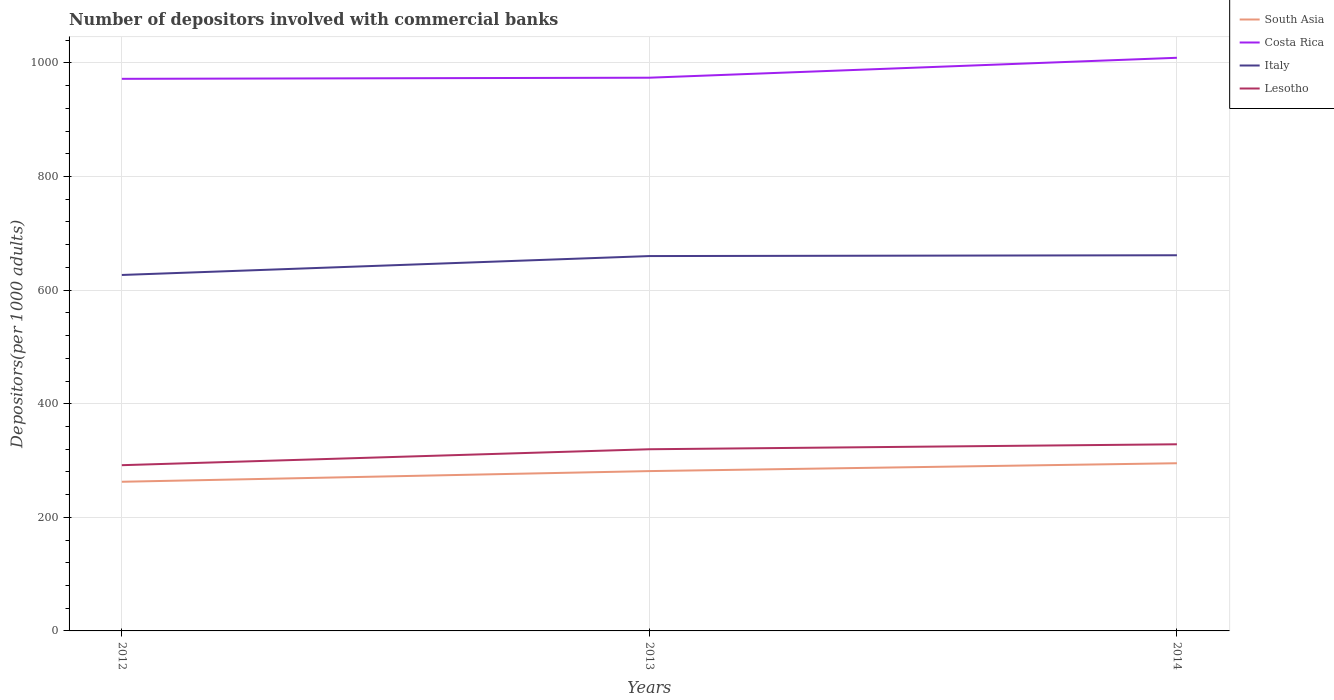Does the line corresponding to Italy intersect with the line corresponding to Costa Rica?
Offer a very short reply. No. Across all years, what is the maximum number of depositors involved with commercial banks in South Asia?
Your answer should be compact. 262.6. In which year was the number of depositors involved with commercial banks in Lesotho maximum?
Your answer should be compact. 2012. What is the total number of depositors involved with commercial banks in Costa Rica in the graph?
Your answer should be compact. -37.08. What is the difference between the highest and the second highest number of depositors involved with commercial banks in South Asia?
Offer a terse response. 32.63. What is the difference between the highest and the lowest number of depositors involved with commercial banks in South Asia?
Offer a very short reply. 2. What is the difference between two consecutive major ticks on the Y-axis?
Make the answer very short. 200. Does the graph contain grids?
Ensure brevity in your answer.  Yes. Where does the legend appear in the graph?
Your answer should be compact. Top right. How many legend labels are there?
Your answer should be compact. 4. How are the legend labels stacked?
Your answer should be compact. Vertical. What is the title of the graph?
Your response must be concise. Number of depositors involved with commercial banks. Does "Turks and Caicos Islands" appear as one of the legend labels in the graph?
Your response must be concise. No. What is the label or title of the Y-axis?
Offer a terse response. Depositors(per 1000 adults). What is the Depositors(per 1000 adults) of South Asia in 2012?
Make the answer very short. 262.6. What is the Depositors(per 1000 adults) of Costa Rica in 2012?
Keep it short and to the point. 972. What is the Depositors(per 1000 adults) of Italy in 2012?
Offer a terse response. 626.68. What is the Depositors(per 1000 adults) of Lesotho in 2012?
Provide a short and direct response. 291.78. What is the Depositors(per 1000 adults) in South Asia in 2013?
Make the answer very short. 281.38. What is the Depositors(per 1000 adults) of Costa Rica in 2013?
Provide a succinct answer. 974. What is the Depositors(per 1000 adults) in Italy in 2013?
Your response must be concise. 659.98. What is the Depositors(per 1000 adults) in Lesotho in 2013?
Your response must be concise. 319.84. What is the Depositors(per 1000 adults) of South Asia in 2014?
Provide a succinct answer. 295.23. What is the Depositors(per 1000 adults) of Costa Rica in 2014?
Offer a terse response. 1009.08. What is the Depositors(per 1000 adults) in Italy in 2014?
Offer a terse response. 661.41. What is the Depositors(per 1000 adults) in Lesotho in 2014?
Your answer should be very brief. 328.59. Across all years, what is the maximum Depositors(per 1000 adults) of South Asia?
Give a very brief answer. 295.23. Across all years, what is the maximum Depositors(per 1000 adults) of Costa Rica?
Offer a terse response. 1009.08. Across all years, what is the maximum Depositors(per 1000 adults) of Italy?
Keep it short and to the point. 661.41. Across all years, what is the maximum Depositors(per 1000 adults) of Lesotho?
Offer a terse response. 328.59. Across all years, what is the minimum Depositors(per 1000 adults) of South Asia?
Your response must be concise. 262.6. Across all years, what is the minimum Depositors(per 1000 adults) of Costa Rica?
Your answer should be compact. 972. Across all years, what is the minimum Depositors(per 1000 adults) of Italy?
Keep it short and to the point. 626.68. Across all years, what is the minimum Depositors(per 1000 adults) of Lesotho?
Provide a succinct answer. 291.78. What is the total Depositors(per 1000 adults) of South Asia in the graph?
Offer a terse response. 839.21. What is the total Depositors(per 1000 adults) of Costa Rica in the graph?
Give a very brief answer. 2955.08. What is the total Depositors(per 1000 adults) of Italy in the graph?
Your answer should be very brief. 1948.07. What is the total Depositors(per 1000 adults) in Lesotho in the graph?
Your response must be concise. 940.21. What is the difference between the Depositors(per 1000 adults) of South Asia in 2012 and that in 2013?
Your answer should be very brief. -18.78. What is the difference between the Depositors(per 1000 adults) in Costa Rica in 2012 and that in 2013?
Give a very brief answer. -2. What is the difference between the Depositors(per 1000 adults) of Italy in 2012 and that in 2013?
Your response must be concise. -33.3. What is the difference between the Depositors(per 1000 adults) of Lesotho in 2012 and that in 2013?
Offer a terse response. -28.06. What is the difference between the Depositors(per 1000 adults) of South Asia in 2012 and that in 2014?
Provide a succinct answer. -32.63. What is the difference between the Depositors(per 1000 adults) in Costa Rica in 2012 and that in 2014?
Offer a terse response. -37.08. What is the difference between the Depositors(per 1000 adults) of Italy in 2012 and that in 2014?
Ensure brevity in your answer.  -34.73. What is the difference between the Depositors(per 1000 adults) of Lesotho in 2012 and that in 2014?
Provide a succinct answer. -36.8. What is the difference between the Depositors(per 1000 adults) of South Asia in 2013 and that in 2014?
Give a very brief answer. -13.85. What is the difference between the Depositors(per 1000 adults) in Costa Rica in 2013 and that in 2014?
Your response must be concise. -35.08. What is the difference between the Depositors(per 1000 adults) in Italy in 2013 and that in 2014?
Your answer should be compact. -1.43. What is the difference between the Depositors(per 1000 adults) in Lesotho in 2013 and that in 2014?
Ensure brevity in your answer.  -8.74. What is the difference between the Depositors(per 1000 adults) in South Asia in 2012 and the Depositors(per 1000 adults) in Costa Rica in 2013?
Ensure brevity in your answer.  -711.4. What is the difference between the Depositors(per 1000 adults) of South Asia in 2012 and the Depositors(per 1000 adults) of Italy in 2013?
Offer a very short reply. -397.38. What is the difference between the Depositors(per 1000 adults) in South Asia in 2012 and the Depositors(per 1000 adults) in Lesotho in 2013?
Provide a short and direct response. -57.24. What is the difference between the Depositors(per 1000 adults) of Costa Rica in 2012 and the Depositors(per 1000 adults) of Italy in 2013?
Your answer should be very brief. 312.02. What is the difference between the Depositors(per 1000 adults) in Costa Rica in 2012 and the Depositors(per 1000 adults) in Lesotho in 2013?
Provide a short and direct response. 652.16. What is the difference between the Depositors(per 1000 adults) of Italy in 2012 and the Depositors(per 1000 adults) of Lesotho in 2013?
Ensure brevity in your answer.  306.84. What is the difference between the Depositors(per 1000 adults) in South Asia in 2012 and the Depositors(per 1000 adults) in Costa Rica in 2014?
Your answer should be compact. -746.48. What is the difference between the Depositors(per 1000 adults) in South Asia in 2012 and the Depositors(per 1000 adults) in Italy in 2014?
Make the answer very short. -398.81. What is the difference between the Depositors(per 1000 adults) in South Asia in 2012 and the Depositors(per 1000 adults) in Lesotho in 2014?
Offer a very short reply. -65.99. What is the difference between the Depositors(per 1000 adults) of Costa Rica in 2012 and the Depositors(per 1000 adults) of Italy in 2014?
Offer a very short reply. 310.59. What is the difference between the Depositors(per 1000 adults) in Costa Rica in 2012 and the Depositors(per 1000 adults) in Lesotho in 2014?
Keep it short and to the point. 643.42. What is the difference between the Depositors(per 1000 adults) in Italy in 2012 and the Depositors(per 1000 adults) in Lesotho in 2014?
Keep it short and to the point. 298.09. What is the difference between the Depositors(per 1000 adults) of South Asia in 2013 and the Depositors(per 1000 adults) of Costa Rica in 2014?
Your answer should be compact. -727.7. What is the difference between the Depositors(per 1000 adults) of South Asia in 2013 and the Depositors(per 1000 adults) of Italy in 2014?
Give a very brief answer. -380.03. What is the difference between the Depositors(per 1000 adults) of South Asia in 2013 and the Depositors(per 1000 adults) of Lesotho in 2014?
Offer a very short reply. -47.2. What is the difference between the Depositors(per 1000 adults) in Costa Rica in 2013 and the Depositors(per 1000 adults) in Italy in 2014?
Give a very brief answer. 312.59. What is the difference between the Depositors(per 1000 adults) of Costa Rica in 2013 and the Depositors(per 1000 adults) of Lesotho in 2014?
Your response must be concise. 645.42. What is the difference between the Depositors(per 1000 adults) in Italy in 2013 and the Depositors(per 1000 adults) in Lesotho in 2014?
Make the answer very short. 331.39. What is the average Depositors(per 1000 adults) of South Asia per year?
Keep it short and to the point. 279.74. What is the average Depositors(per 1000 adults) of Costa Rica per year?
Ensure brevity in your answer.  985.03. What is the average Depositors(per 1000 adults) in Italy per year?
Give a very brief answer. 649.36. What is the average Depositors(per 1000 adults) in Lesotho per year?
Provide a short and direct response. 313.4. In the year 2012, what is the difference between the Depositors(per 1000 adults) in South Asia and Depositors(per 1000 adults) in Costa Rica?
Offer a terse response. -709.4. In the year 2012, what is the difference between the Depositors(per 1000 adults) of South Asia and Depositors(per 1000 adults) of Italy?
Offer a terse response. -364.08. In the year 2012, what is the difference between the Depositors(per 1000 adults) of South Asia and Depositors(per 1000 adults) of Lesotho?
Ensure brevity in your answer.  -29.18. In the year 2012, what is the difference between the Depositors(per 1000 adults) of Costa Rica and Depositors(per 1000 adults) of Italy?
Provide a short and direct response. 345.32. In the year 2012, what is the difference between the Depositors(per 1000 adults) of Costa Rica and Depositors(per 1000 adults) of Lesotho?
Your answer should be compact. 680.22. In the year 2012, what is the difference between the Depositors(per 1000 adults) of Italy and Depositors(per 1000 adults) of Lesotho?
Provide a succinct answer. 334.9. In the year 2013, what is the difference between the Depositors(per 1000 adults) in South Asia and Depositors(per 1000 adults) in Costa Rica?
Keep it short and to the point. -692.62. In the year 2013, what is the difference between the Depositors(per 1000 adults) of South Asia and Depositors(per 1000 adults) of Italy?
Provide a short and direct response. -378.6. In the year 2013, what is the difference between the Depositors(per 1000 adults) in South Asia and Depositors(per 1000 adults) in Lesotho?
Offer a terse response. -38.46. In the year 2013, what is the difference between the Depositors(per 1000 adults) of Costa Rica and Depositors(per 1000 adults) of Italy?
Ensure brevity in your answer.  314.02. In the year 2013, what is the difference between the Depositors(per 1000 adults) of Costa Rica and Depositors(per 1000 adults) of Lesotho?
Provide a short and direct response. 654.16. In the year 2013, what is the difference between the Depositors(per 1000 adults) in Italy and Depositors(per 1000 adults) in Lesotho?
Offer a terse response. 340.14. In the year 2014, what is the difference between the Depositors(per 1000 adults) in South Asia and Depositors(per 1000 adults) in Costa Rica?
Offer a terse response. -713.85. In the year 2014, what is the difference between the Depositors(per 1000 adults) of South Asia and Depositors(per 1000 adults) of Italy?
Offer a very short reply. -366.18. In the year 2014, what is the difference between the Depositors(per 1000 adults) of South Asia and Depositors(per 1000 adults) of Lesotho?
Your answer should be very brief. -33.35. In the year 2014, what is the difference between the Depositors(per 1000 adults) in Costa Rica and Depositors(per 1000 adults) in Italy?
Keep it short and to the point. 347.67. In the year 2014, what is the difference between the Depositors(per 1000 adults) in Costa Rica and Depositors(per 1000 adults) in Lesotho?
Keep it short and to the point. 680.49. In the year 2014, what is the difference between the Depositors(per 1000 adults) of Italy and Depositors(per 1000 adults) of Lesotho?
Your answer should be very brief. 332.82. What is the ratio of the Depositors(per 1000 adults) in South Asia in 2012 to that in 2013?
Offer a terse response. 0.93. What is the ratio of the Depositors(per 1000 adults) in Italy in 2012 to that in 2013?
Provide a succinct answer. 0.95. What is the ratio of the Depositors(per 1000 adults) in Lesotho in 2012 to that in 2013?
Make the answer very short. 0.91. What is the ratio of the Depositors(per 1000 adults) in South Asia in 2012 to that in 2014?
Provide a short and direct response. 0.89. What is the ratio of the Depositors(per 1000 adults) in Costa Rica in 2012 to that in 2014?
Provide a short and direct response. 0.96. What is the ratio of the Depositors(per 1000 adults) in Italy in 2012 to that in 2014?
Provide a short and direct response. 0.95. What is the ratio of the Depositors(per 1000 adults) of Lesotho in 2012 to that in 2014?
Offer a very short reply. 0.89. What is the ratio of the Depositors(per 1000 adults) of South Asia in 2013 to that in 2014?
Provide a succinct answer. 0.95. What is the ratio of the Depositors(per 1000 adults) of Costa Rica in 2013 to that in 2014?
Provide a short and direct response. 0.97. What is the ratio of the Depositors(per 1000 adults) in Italy in 2013 to that in 2014?
Offer a very short reply. 1. What is the ratio of the Depositors(per 1000 adults) of Lesotho in 2013 to that in 2014?
Ensure brevity in your answer.  0.97. What is the difference between the highest and the second highest Depositors(per 1000 adults) of South Asia?
Ensure brevity in your answer.  13.85. What is the difference between the highest and the second highest Depositors(per 1000 adults) in Costa Rica?
Your response must be concise. 35.08. What is the difference between the highest and the second highest Depositors(per 1000 adults) in Italy?
Provide a succinct answer. 1.43. What is the difference between the highest and the second highest Depositors(per 1000 adults) in Lesotho?
Ensure brevity in your answer.  8.74. What is the difference between the highest and the lowest Depositors(per 1000 adults) of South Asia?
Provide a short and direct response. 32.63. What is the difference between the highest and the lowest Depositors(per 1000 adults) of Costa Rica?
Offer a terse response. 37.08. What is the difference between the highest and the lowest Depositors(per 1000 adults) of Italy?
Make the answer very short. 34.73. What is the difference between the highest and the lowest Depositors(per 1000 adults) in Lesotho?
Your answer should be compact. 36.8. 